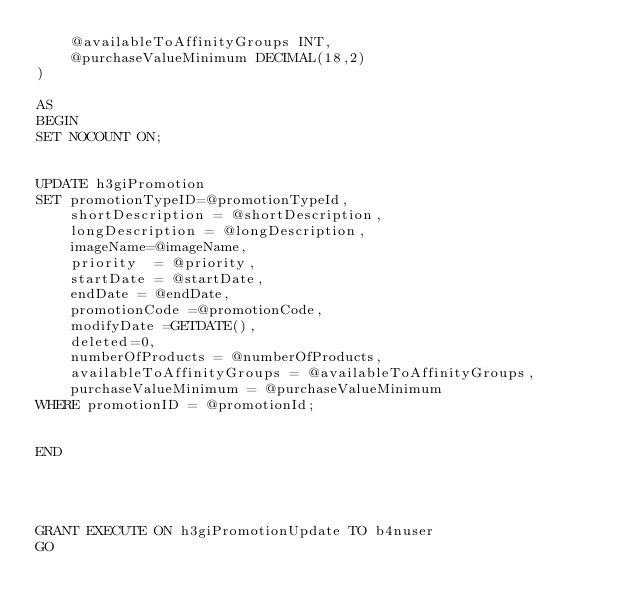<code> <loc_0><loc_0><loc_500><loc_500><_SQL_>	@availableToAffinityGroups INT,
	@purchaseValueMinimum DECIMAL(18,2)
)

AS
BEGIN
SET NOCOUNT ON;


UPDATE h3giPromotion
SET promotionTypeID=@promotionTypeId,
	shortDescription = @shortDescription,
	longDescription = @longDescription,
	imageName=@imageName,
	priority  = @priority,
	startDate = @startDate,
	endDate = @endDate,
	promotionCode =@promotionCode,
	modifyDate =GETDATE(),
	deleted=0,
	numberOfProducts = @numberOfProducts,
	availableToAffinityGroups = @availableToAffinityGroups,
	purchaseValueMinimum = @purchaseValueMinimum
WHERE promotionID = @promotionId;


END




GRANT EXECUTE ON h3giPromotionUpdate TO b4nuser
GO
</code> 